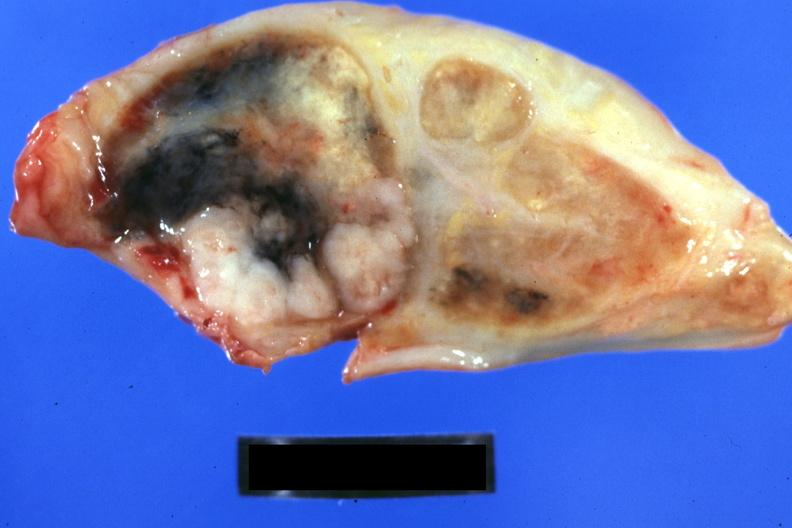what does this image show?
Answer the question using a single word or phrase. Obvious tumor with necrosis and anthracotic pigment 44yo bf adenocarcinoma of lung giant cell type 